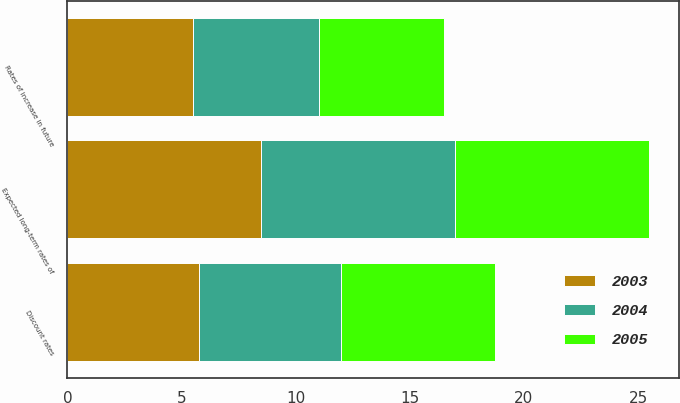<chart> <loc_0><loc_0><loc_500><loc_500><stacked_bar_chart><ecel><fcel>Discount rates<fcel>Expected long-term rates of<fcel>Rates of increase in future<nl><fcel>2003<fcel>5.75<fcel>8.5<fcel>5.5<nl><fcel>2004<fcel>6.25<fcel>8.5<fcel>5.5<nl><fcel>2005<fcel>6.75<fcel>8.5<fcel>5.5<nl></chart> 